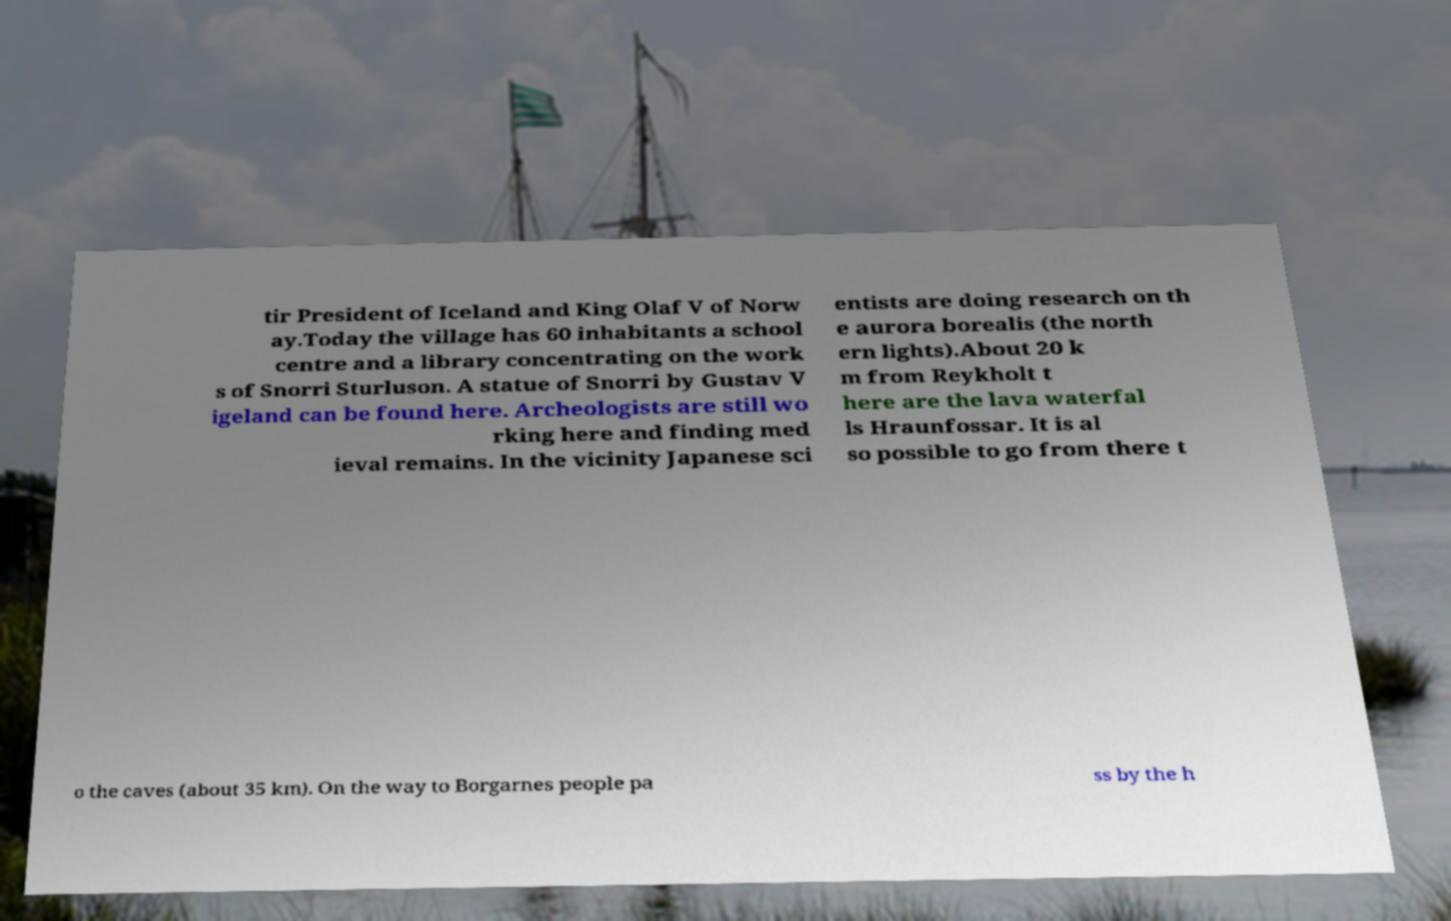Could you extract and type out the text from this image? tir President of Iceland and King Olaf V of Norw ay.Today the village has 60 inhabitants a school centre and a library concentrating on the work s of Snorri Sturluson. A statue of Snorri by Gustav V igeland can be found here. Archeologists are still wo rking here and finding med ieval remains. In the vicinity Japanese sci entists are doing research on th e aurora borealis (the north ern lights).About 20 k m from Reykholt t here are the lava waterfal ls Hraunfossar. It is al so possible to go from there t o the caves (about 35 km). On the way to Borgarnes people pa ss by the h 